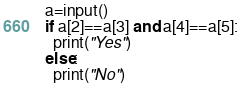Convert code to text. <code><loc_0><loc_0><loc_500><loc_500><_Python_>a=input()
if a[2]==a[3] and a[4]==a[5]:
  print("Yes")
else:
  print("No")</code> 